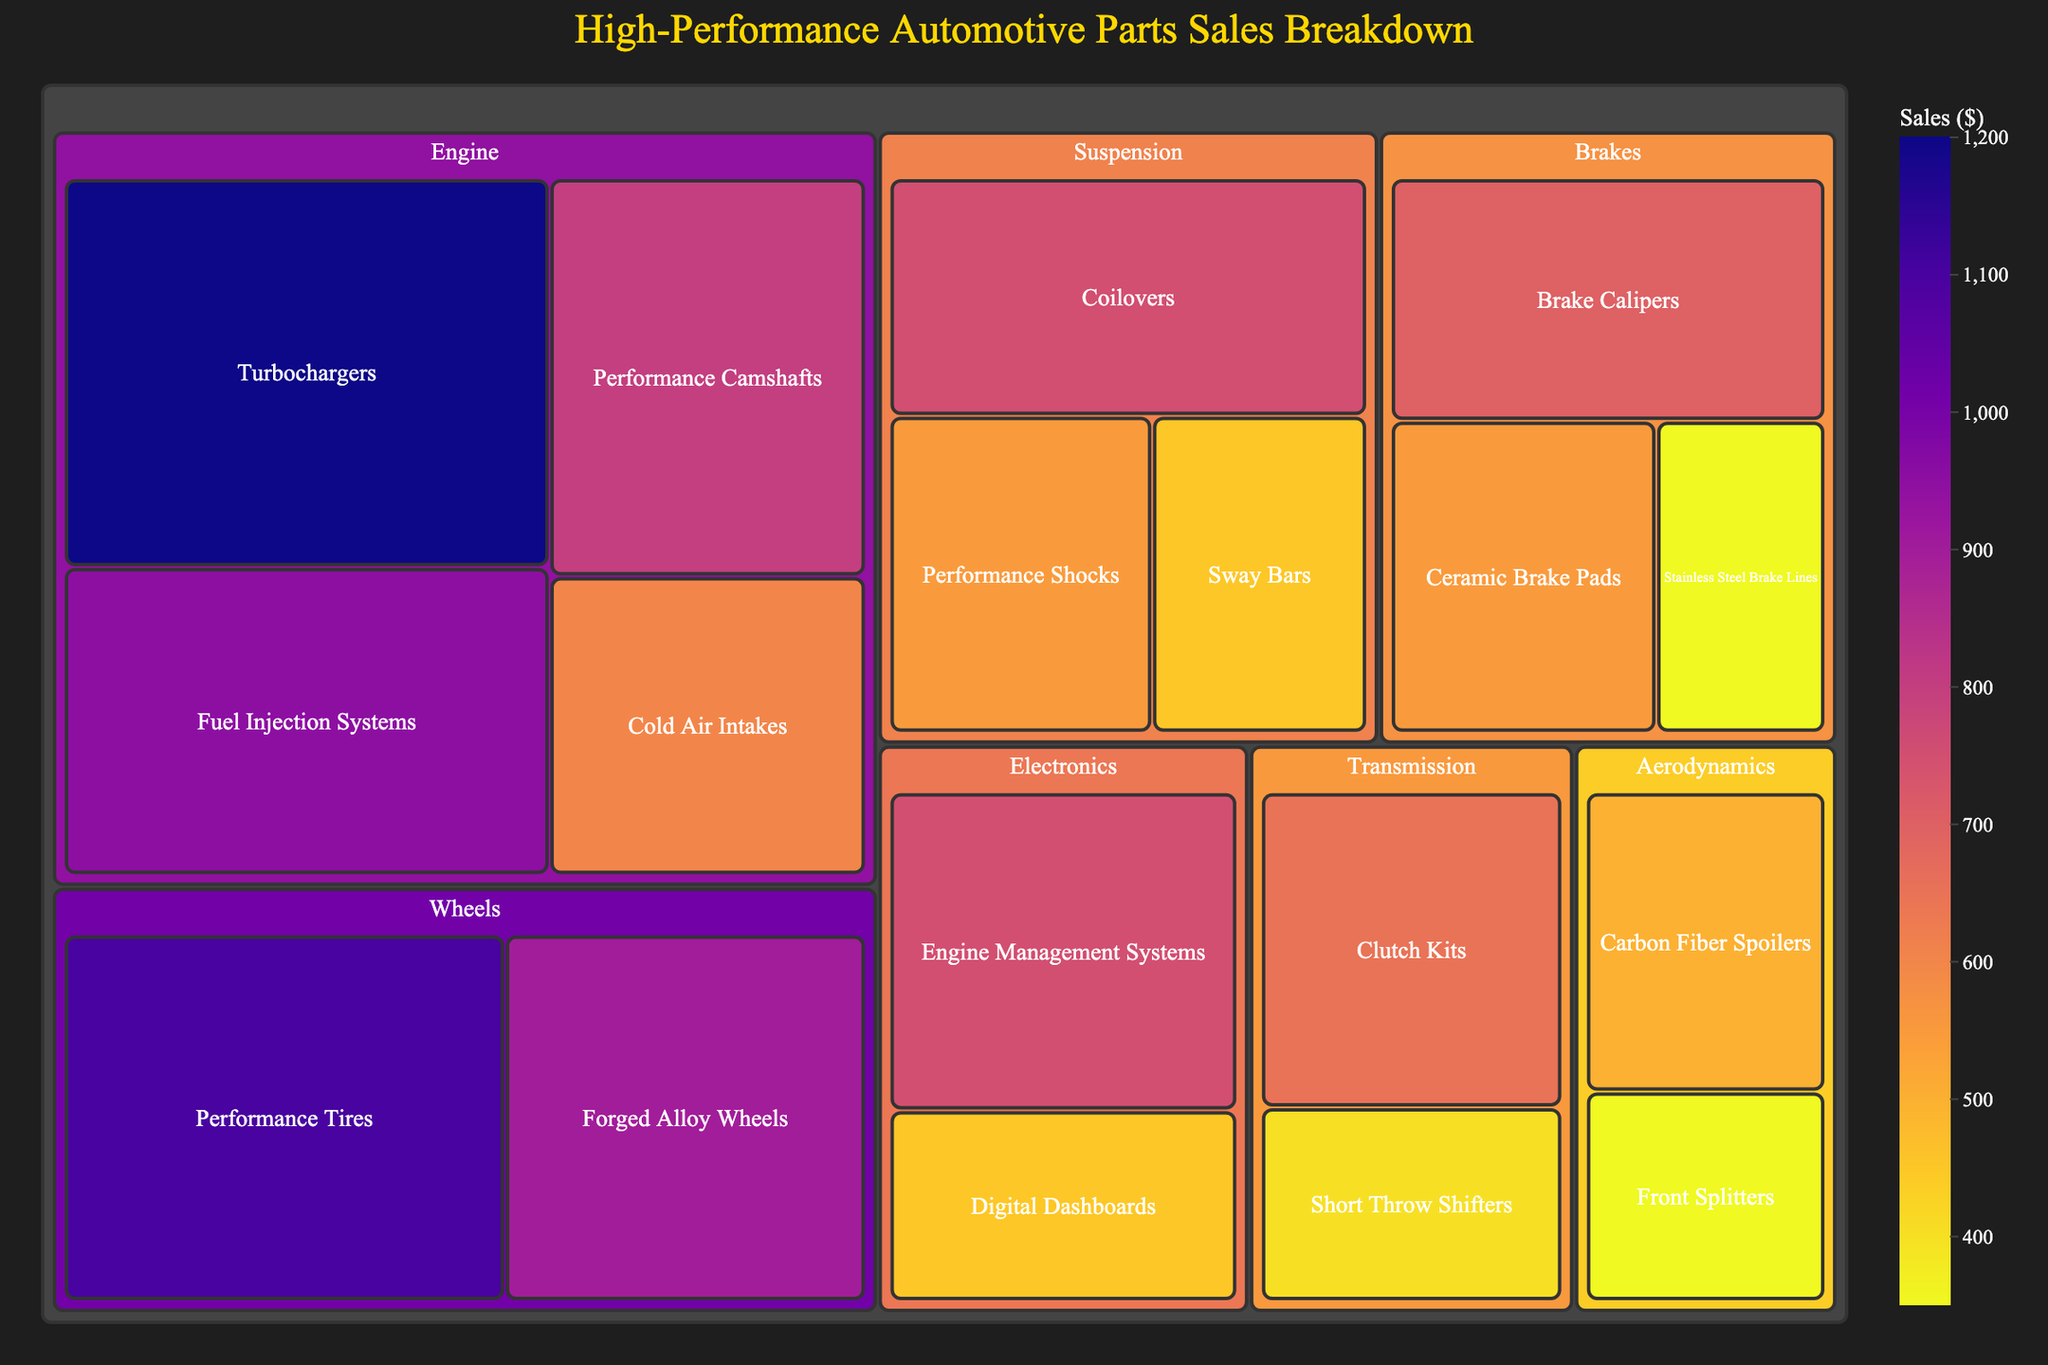What's the title of the treemap? The title is usually located at the top center of the figure. In this case, it reads "High-Performance Automotive Parts Sales Breakdown".
Answer: High-Performance Automotive Parts Sales Breakdown What subcategory has the highest sales value within the Engine category? By visually inspecting the size of the blocks under the Engine category, the Turbochargers block appears the largest, indicating the highest sales value.
Answer: Turbochargers Which category has the lowest total sales value? By comparing the overall sizes of the main blocks representing each category, Aerodynamics appears to be the smallest, indicating the lowest total sales value.
Answer: Aerodynamics How do the sales of Forged Alloy Wheels compare to those of Performance Tires? Look at the blocks for Wheels' subcategories. Both blocks are quite large, but Performance Tires is larger than Forged Alloy Wheels. So, sales of Performance Tires are higher.
Answer: Performance Tires have higher sales What is the combined sales value of Performance Shocks and Performance Shocks? In the Suspension category, find the values for Performance Shocks and Sway Bars, then add: Performance Shocks ($550) and Sway Bars ($450). The sum is $550 + $450 = $1,000.
Answer: $1,000 Which subcategory in Brakes has the lowest sales value? Within the Brakes category, inspect the respective subcategory blocks. The Stainless Steel Brake Lines block is the smallest, indicating the lowest sales value.
Answer: Stainless Steel Brake Lines What is the total sales value for the Electronics category? Sum the values for the subcategories under Electronics: Engine Management Systems ($750) and Digital Dashboards ($450). The total is $750 + $450 = $1,200.
Answer: $1,200 If the sales for Performance Camshafts and Short Throw Shifters were combined, how would their total compare to Fuel Injection Systems? Combine sales: Performance Camshafts ($800) + Short Throw Shifters ($400) = $1,200. Compare with Fuel Injection Systems, which is $950. $1,200 is greater than $950.
Answer: Combined sales are greater Which category is represented by the most subcategories? Count the subcategories for each main category. Engine has Turbochargers, Performance Camshafts, Fuel Injection Systems, and Cold Air Intakes, totaling 4 subcategories.
Answer: Engine What is the percent difference in sales value between Clutch Kits and Carbon Fiber Spoilers? Calculate difference: $650 (Clutch Kits) - $500 (Carbon Fiber Spoilers) = $150. Percent difference: ($150 / $500) * 100 = 30%.
Answer: 30% 